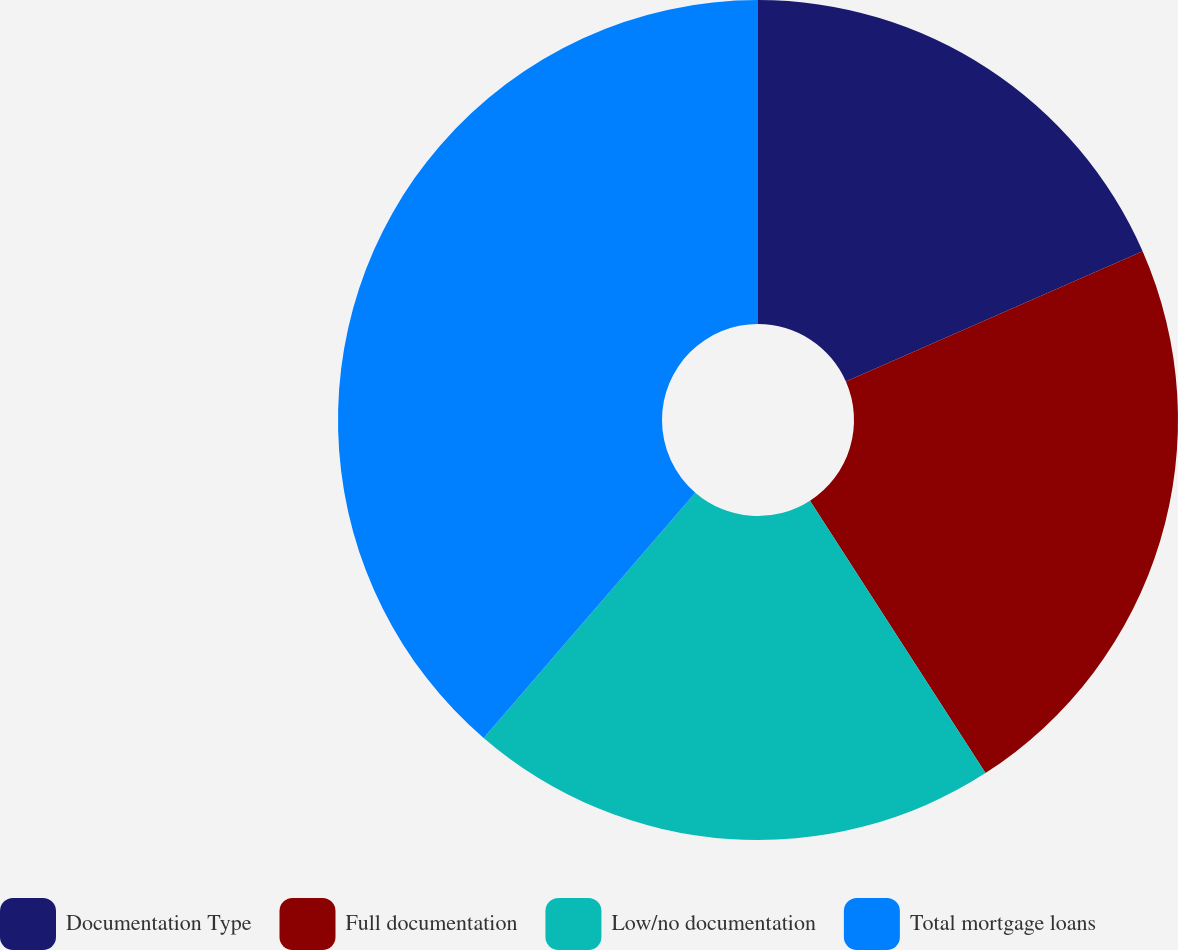Convert chart to OTSL. <chart><loc_0><loc_0><loc_500><loc_500><pie_chart><fcel>Documentation Type<fcel>Full documentation<fcel>Low/no documentation<fcel>Total mortgage loans<nl><fcel>18.42%<fcel>22.47%<fcel>20.44%<fcel>38.67%<nl></chart> 